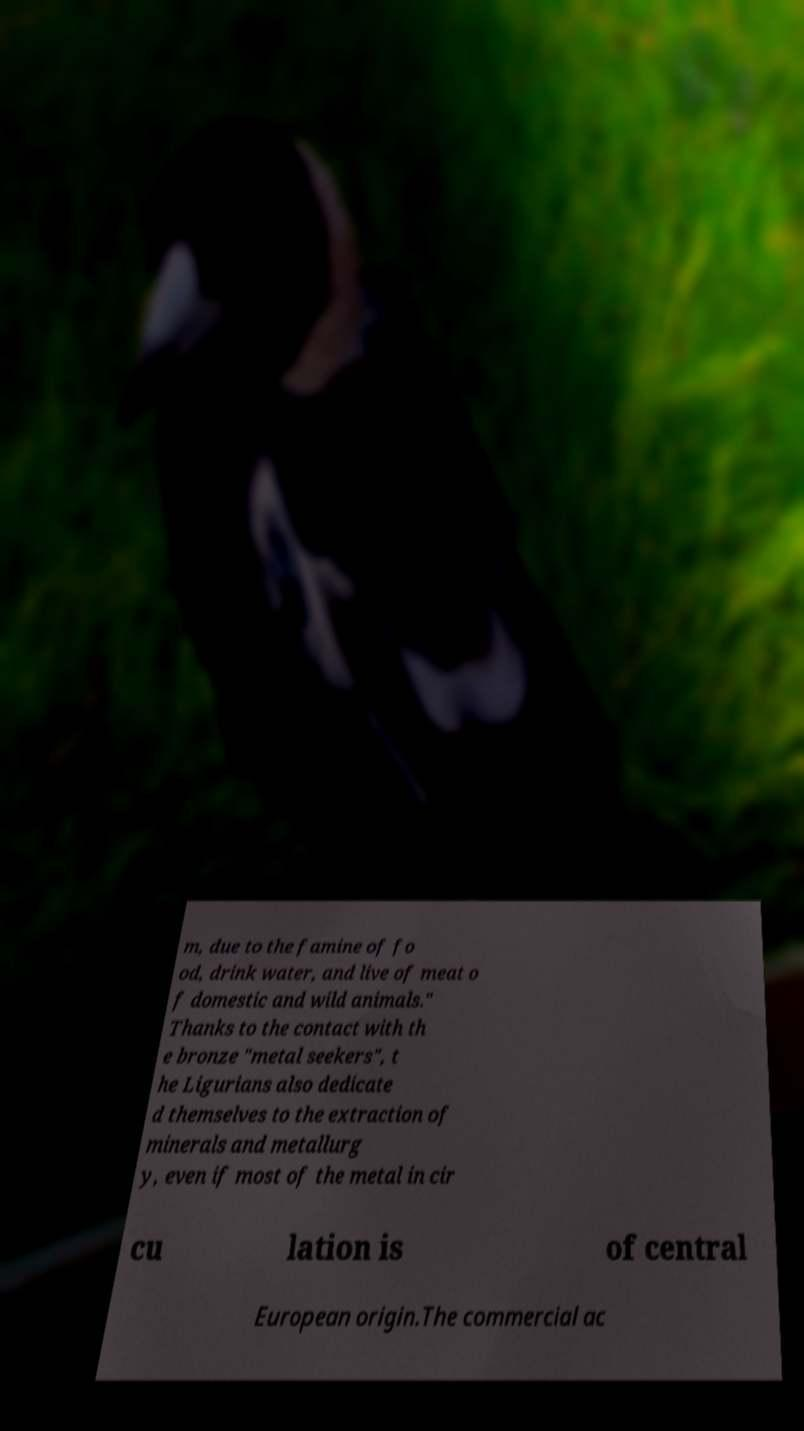Can you read and provide the text displayed in the image?This photo seems to have some interesting text. Can you extract and type it out for me? m, due to the famine of fo od, drink water, and live of meat o f domestic and wild animals." Thanks to the contact with th e bronze "metal seekers", t he Ligurians also dedicate d themselves to the extraction of minerals and metallurg y, even if most of the metal in cir cu lation is of central European origin.The commercial ac 